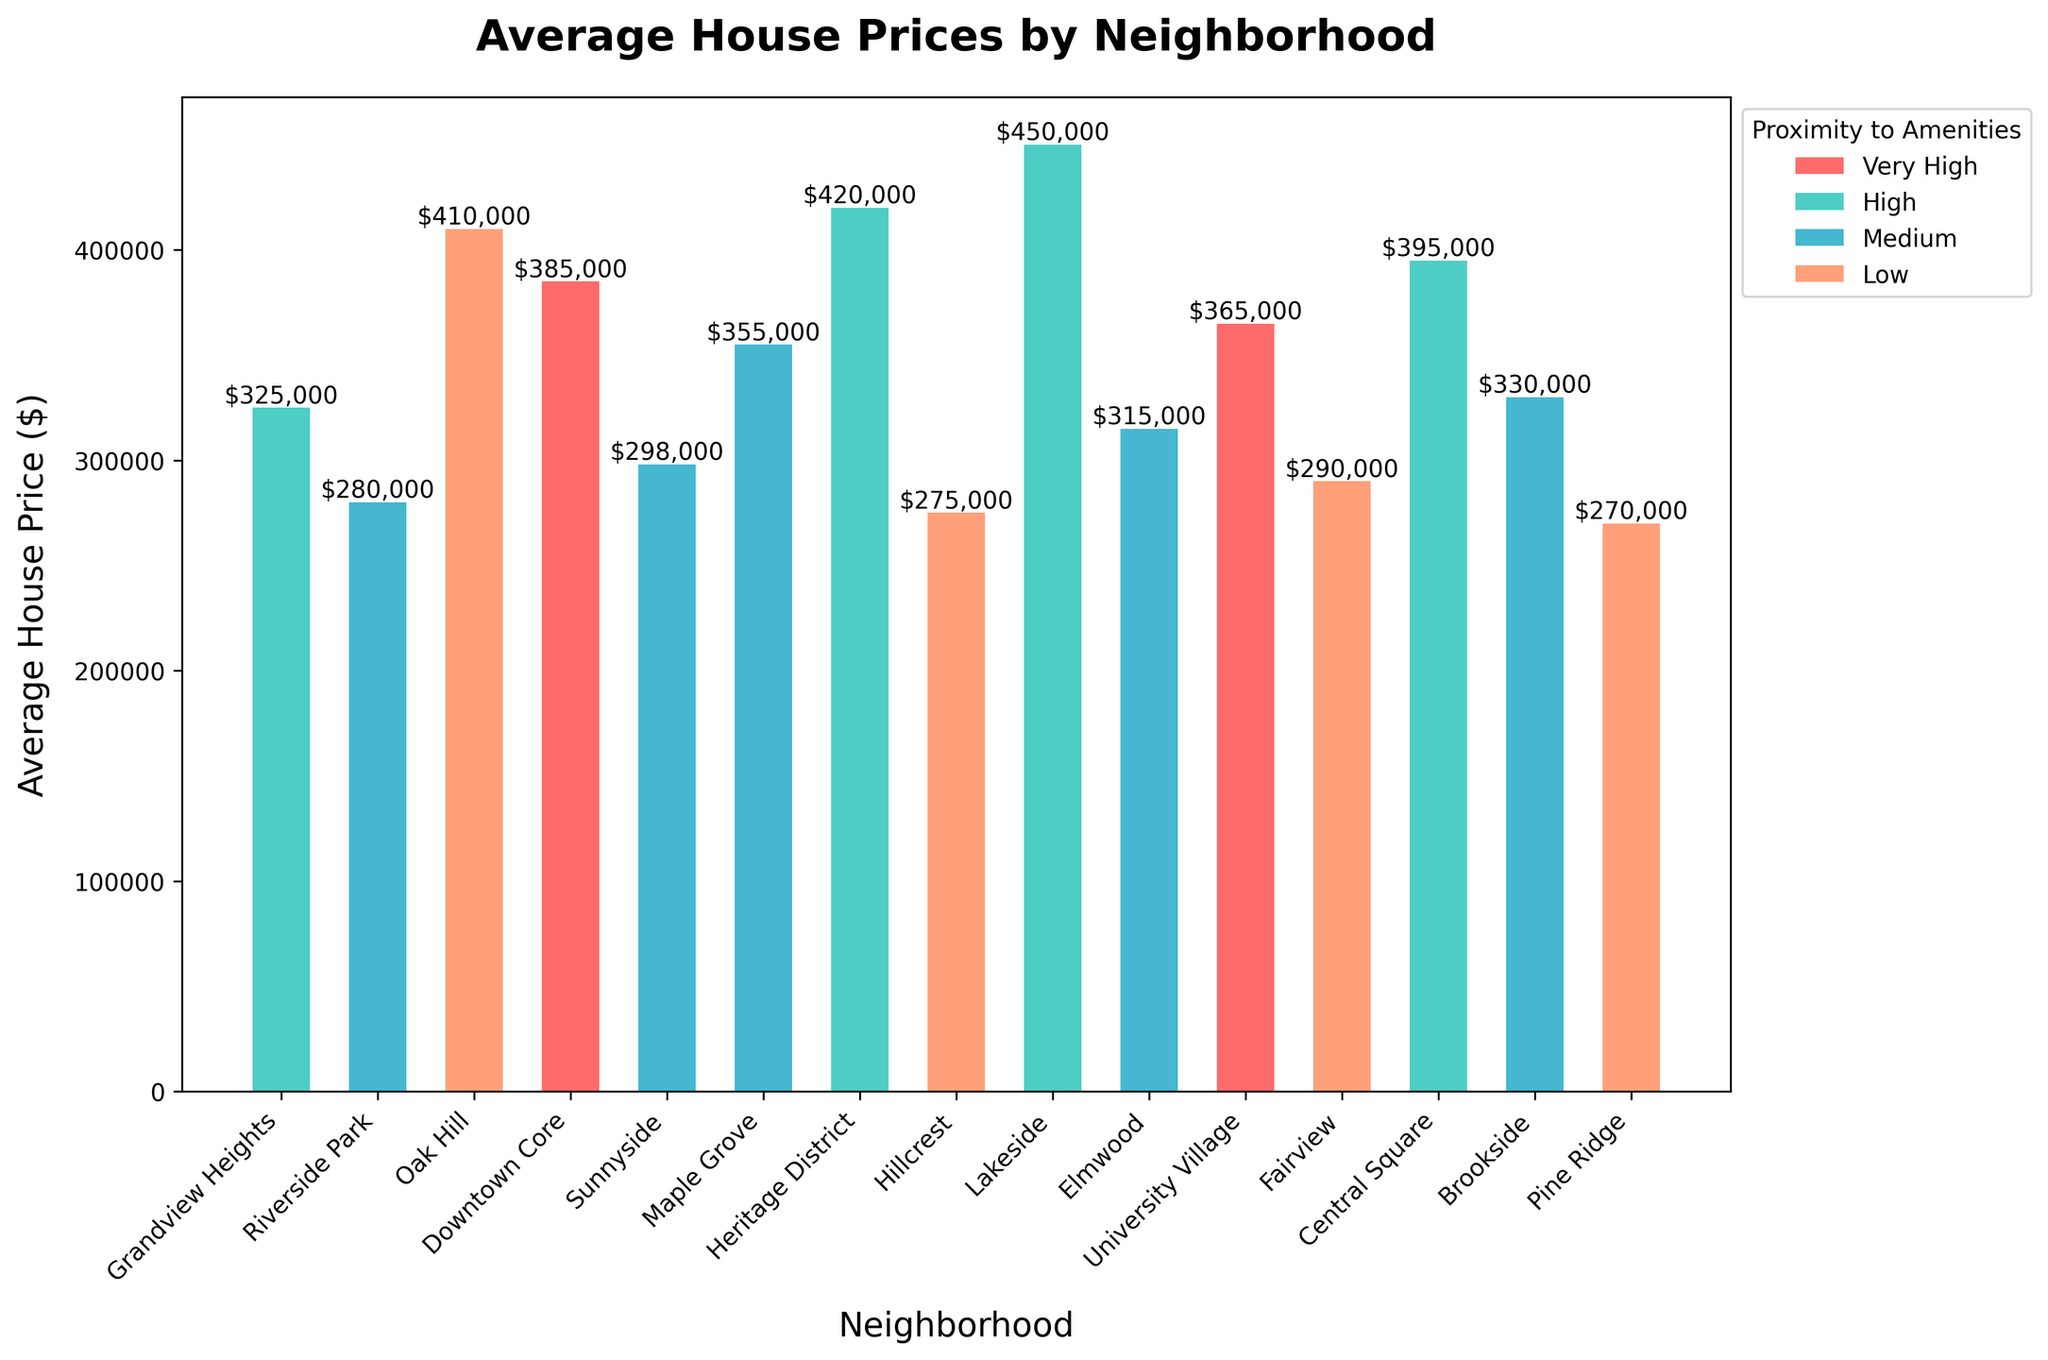What neighborhood has the lowest average house price? The lowest bar in the chart represents the neighborhood with the lowest average house price. Pine Ridge has a bar height of $270,000, which is the lowest amongst all.
Answer: Pine Ridge Which neighborhoods have a very high proximity to amenities and how do their average house prices compare? The bars for neighborhoods with very high proximity to amenities are colored differently from others. Based on the legend and colors, Downtown Core ($385,000) and University Village ($365,000) have very high proximity to amenities.
Answer: Downtown Core and University Village What is the difference in average house price between Lakeside and Hillcrest? Look at the heights of the bars for Lakeside and Hillcrest. Lakeside has an average house price of $450,000, while Hillcrest has $275,000. Calculate the difference: $450,000 - $275,000 = $175,000.
Answer: $175,000 Which neighborhood with medium proximity to amenities has the highest average house price? Among the neighborhoods with medium proximity to amenities, find the tallest bar. Maple Grove has the highest bar with $355,000.
Answer: Maple Grove How does the average house price in Heritage District compare to that in Oak Hill? Compare the heights of the bars for Heritage District ($420,000) and Oak Hill ($410,000). Heritage District’s average house price is $10,000 higher than Oak Hill’s.
Answer: Heritage District’s is $10,000 higher Which neighborhoods have an average house price above $400,000? Identify bars higher than the $400,000 mark. The neighborhoods are Oak Hill ($410,000), Heritage District ($420,000), Downtown Core ($385,000), and Lakeside ($450,000).
Answer: Oak Hill, Heritage District, Downtown Core, Lakeside What is the total average house price for neighborhoods with high proximity to amenities? Add up the average house prices of Grandview Heights ($325,000), Heritage District ($420,000), Central Square ($395,000), and Lakeside ($450,000). The total is $1,590,000.
Answer: $1,590,000 Is there a correlation between the proximity to amenities and the average house price? Examine the colors of the bars and their heights. Generally, neighborhoods with higher proximity to amenities (High, Very High) tend to have higher average house prices than those with lower proximity.
Answer: Yes Which neighborhood has the closest average house price to $300,000? Identify the bar heights around $300,000. Elmwood is at $315,000, which is the closest to $300,000.
Answer: Elmwood 